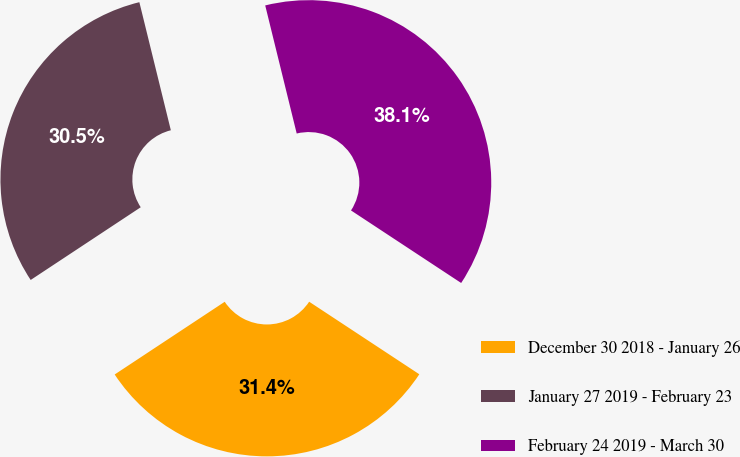Convert chart to OTSL. <chart><loc_0><loc_0><loc_500><loc_500><pie_chart><fcel>December 30 2018 - January 26<fcel>January 27 2019 - February 23<fcel>February 24 2019 - March 30<nl><fcel>31.44%<fcel>30.46%<fcel>38.11%<nl></chart> 